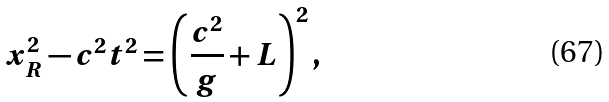<formula> <loc_0><loc_0><loc_500><loc_500>x _ { R } ^ { 2 } - c ^ { 2 } t ^ { 2 } = \left ( \frac { c ^ { 2 } } { g } + L \right ) ^ { 2 } ,</formula> 